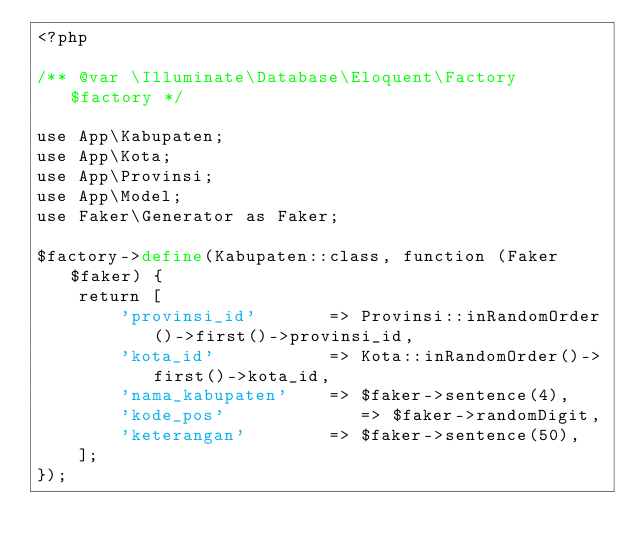Convert code to text. <code><loc_0><loc_0><loc_500><loc_500><_PHP_><?php

/** @var \Illuminate\Database\Eloquent\Factory $factory */

use App\Kabupaten;
use App\Kota;
use App\Provinsi;
use App\Model;
use Faker\Generator as Faker;

$factory->define(Kabupaten::class, function (Faker $faker) {
    return [
        'provinsi_id'       => Provinsi::inRandomOrder()->first()->provinsi_id, 
        'kota_id'           => Kota::inRandomOrder()->first()->kota_id, 
        'nama_kabupaten'    => $faker->sentence(4),
        'kode_pos'             => $faker->randomDigit,
        'keterangan'        => $faker->sentence(50),
    ];
});
</code> 